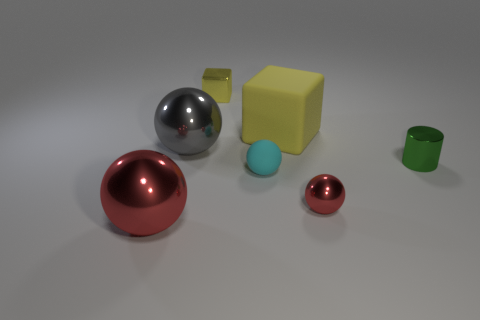Subtract all metallic balls. How many balls are left? 1 Add 2 tiny yellow objects. How many objects exist? 9 Subtract 1 balls. How many balls are left? 3 Subtract all green cylinders. How many red balls are left? 2 Subtract all cylinders. How many objects are left? 6 Subtract all cyan spheres. How many spheres are left? 3 Subtract all spheres. Subtract all big blocks. How many objects are left? 2 Add 4 small cylinders. How many small cylinders are left? 5 Add 6 cyan cylinders. How many cyan cylinders exist? 6 Subtract 1 green cylinders. How many objects are left? 6 